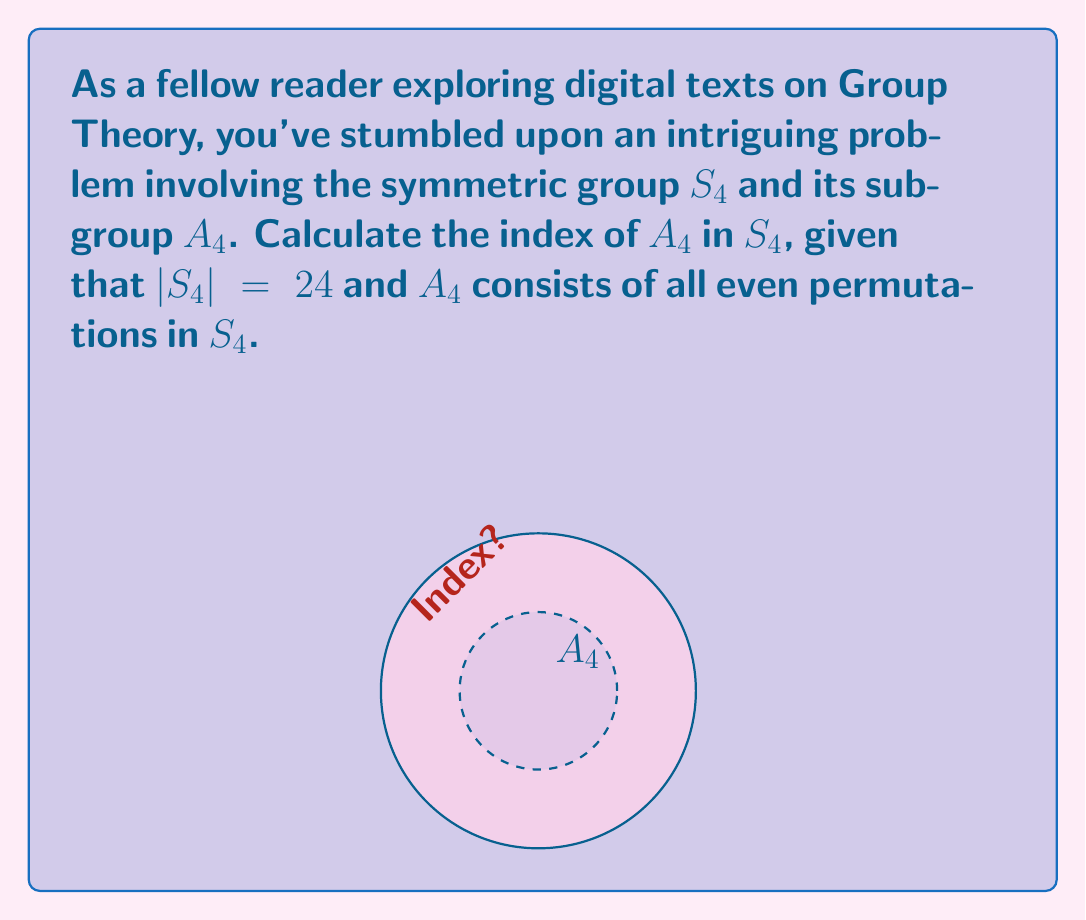Give your solution to this math problem. To calculate the index of $A_4$ in $S_4$, we'll follow these steps:

1) Recall that the index of a subgroup $H$ in a group $G$ is defined as:

   $[G:H] = \frac{|G|}{|H|}$

   where $|G|$ and $|H|$ are the orders (number of elements) of $G$ and $H$ respectively.

2) We're given that $|S_4| = 24$.

3) To find $|A_4|$, we need to determine the number of even permutations in $S_4$:
   - In any symmetric group $S_n$, exactly half of the permutations are even.
   - Therefore, $|A_4| = \frac{1}{2}|S_4| = \frac{1}{2} \cdot 24 = 12$

4) Now we can calculate the index:

   $[S_4:A_4] = \frac{|S_4|}{|A_4|} = \frac{24}{12} = 2$

This result means that there are 2 distinct left (or right) cosets of $A_4$ in $S_4$.
Answer: $[S_4:A_4] = 2$ 